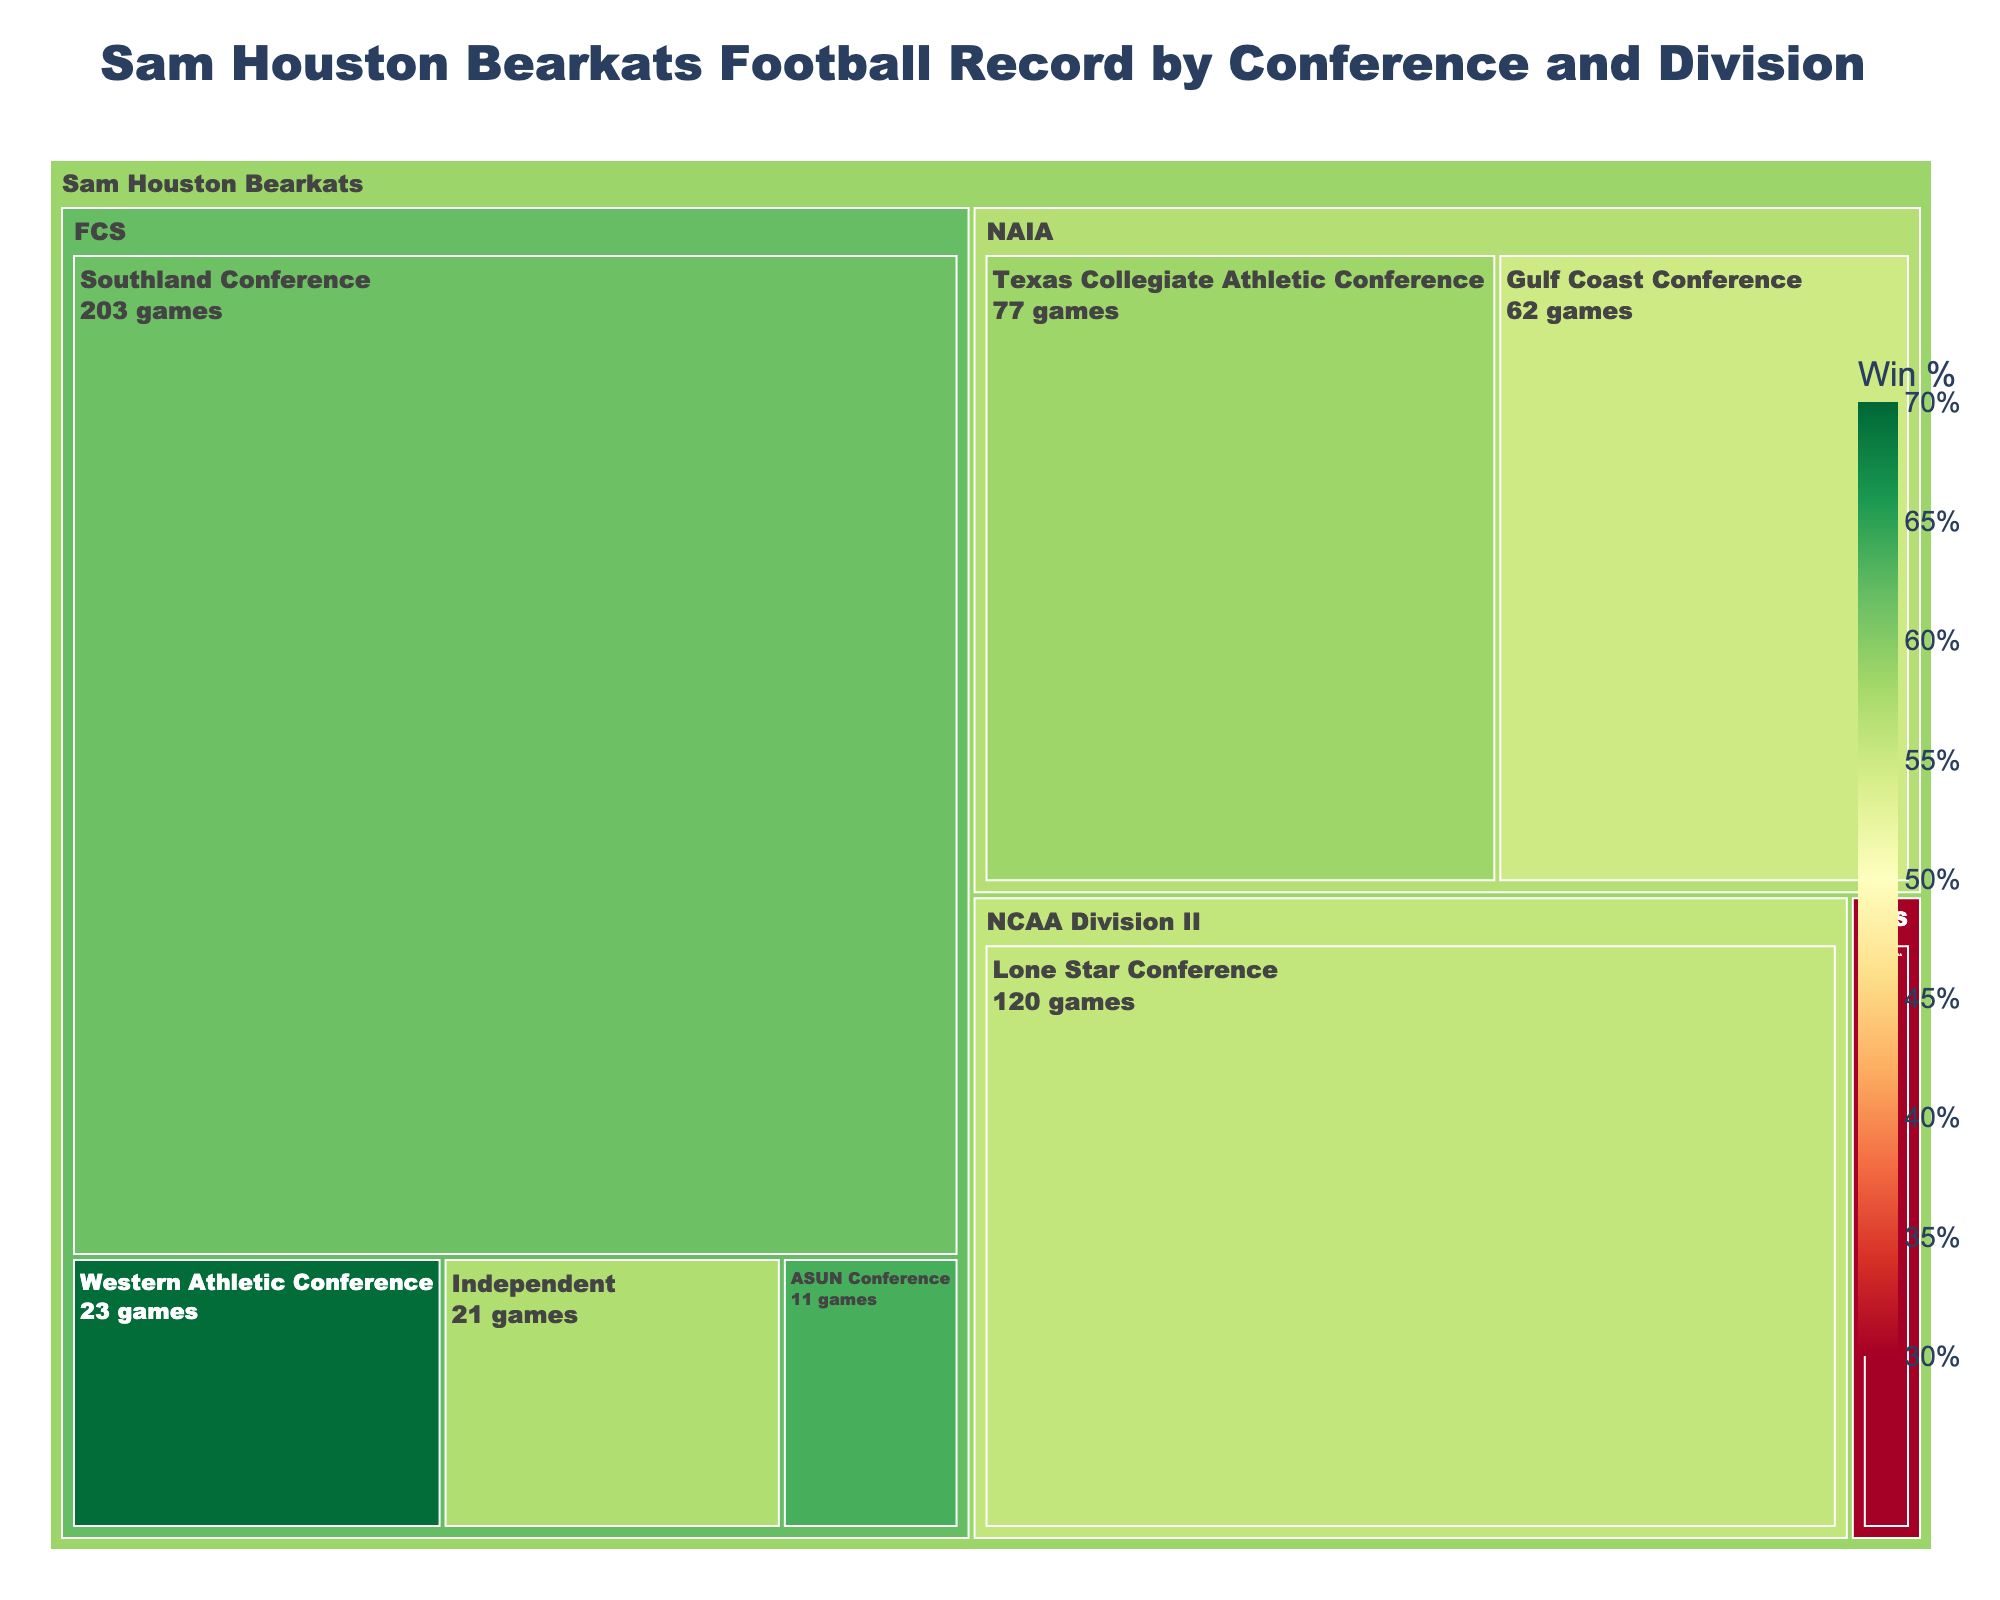Which conference has the highest number of total games played by the Sam Houston Bearkats? By looking at the treemap, the Southland Conference is the largest section, indicating the highest number of games. The total games are the sum of 125 wins and 78 losses.
Answer: Southland Conference What is the win percentage for the Sam Houston Bearkats in the Southland Conference? The hover text for the Southland Conference shows the win percentage. It is calculated as (Wins / Total Games) * 100. For the Southland Conference, it is (125 / (125 + 78)) * 100, which is approximately 61.6%.
Answer: 61.6% In which conference and division did the Bearkats have the fewest total games? The smallest section in the treemap, indicating the fewest games, is for the ASUN Conference in the FCS division. Adding wins and losses gives the total games as 7 + 4.
Answer: ASUN Conference, FCS Between the Western Athletic Conference and the Texas Collegiate Athletic Conference, which has a higher win percentage? By comparing the colors, the Western Athletic Conference section is greener than the Texas Collegiate Athletic Conference section, indicating a higher win percentage. The Western Athletic Conference section has a higher win percentage.
Answer: Western Athletic Conference How many total games did the Bearkats play in the NCAA Division II? Summing up total games in this division, which is represented by the Lone Star Conference section, gives us (67 wins + 53 losses = 120 total games).
Answer: 120 games What is the difference in the number of wins between the Southland Conference and the Gulf Coast Conference? Subtracting the number of wins in the Gulf Coast Conference (45) from the wins in the Southland Conference (125) gives us a difference of 80.
Answer: 80 wins Which division has the highest total number of wins across all conferences? The treemap shows different sections for each division. Summing up the wins from each section, the FCS division (125 + 16 + 7 + 12) totals to 160 wins, which is the highest.
Answer: FCS Which conference has the largest area, and what does it represent? The Southland Conference has the largest area, representing the highest total number of games played. This is evident from the treemap size for this conference.
Answer: Southland Conference What is the win percentage for the Sam Houston Bearkats in the Conference USA? The hover text for Conference USA shows the win percentage calculation. It is (Wins / Total Games) * 100. For Conference USA, it is (3 / (3 + 7)) * 100, which is 30%.
Answer: 30% What is the combined win percentage of the Bearkats in the ASUN and Independent conferences? First, calculate the win percentage for each: ASUN (7/11 * 100 ≈ 63.6%) and Independent (12/21 * 100 ≈ 57.1%). Then average these percentages: (63.6 + 57.1) / 2 ≈ 60.35%.
Answer: 60.35% 